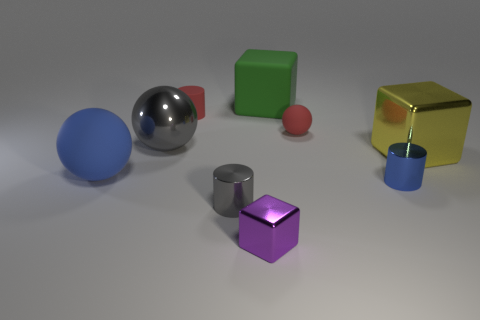Add 1 tiny red matte balls. How many objects exist? 10 Subtract all cubes. How many objects are left? 6 Add 4 yellow metallic objects. How many yellow metallic objects are left? 5 Add 1 purple metallic things. How many purple metallic things exist? 2 Subtract 0 cyan cylinders. How many objects are left? 9 Subtract all tiny red objects. Subtract all small balls. How many objects are left? 6 